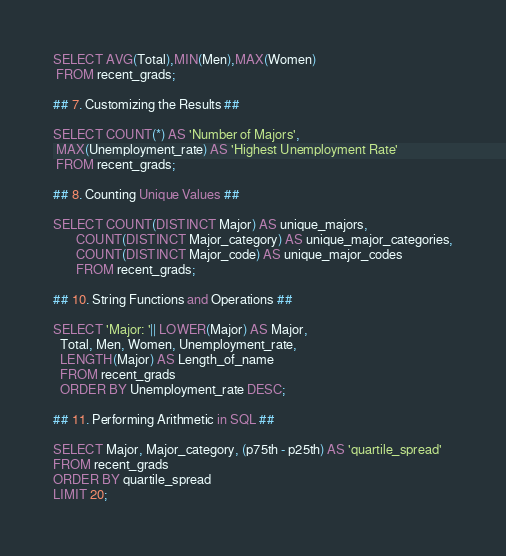<code> <loc_0><loc_0><loc_500><loc_500><_SQL_>
SELECT AVG(Total),MIN(Men),MAX(Women)
 FROM recent_grads;

## 7. Customizing the Results ##

SELECT COUNT(*) AS 'Number of Majors',
 MAX(Unemployment_rate) AS 'Highest Unemployment Rate'
 FROM recent_grads;

## 8. Counting Unique Values ##

SELECT COUNT(DISTINCT Major) AS unique_majors,
       COUNT(DISTINCT Major_category) AS unique_major_categories,
       COUNT(DISTINCT Major_code) AS unique_major_codes
       FROM recent_grads;

## 10. String Functions and Operations ##

SELECT 'Major: '|| LOWER(Major) AS Major,
  Total, Men, Women, Unemployment_rate,
  LENGTH(Major) AS Length_of_name
  FROM recent_grads
  ORDER BY Unemployment_rate DESC;

## 11. Performing Arithmetic in SQL ##

SELECT Major, Major_category, (p75th - p25th) AS 'quartile_spread'
FROM recent_grads
ORDER BY quartile_spread
LIMIT 20;</code> 